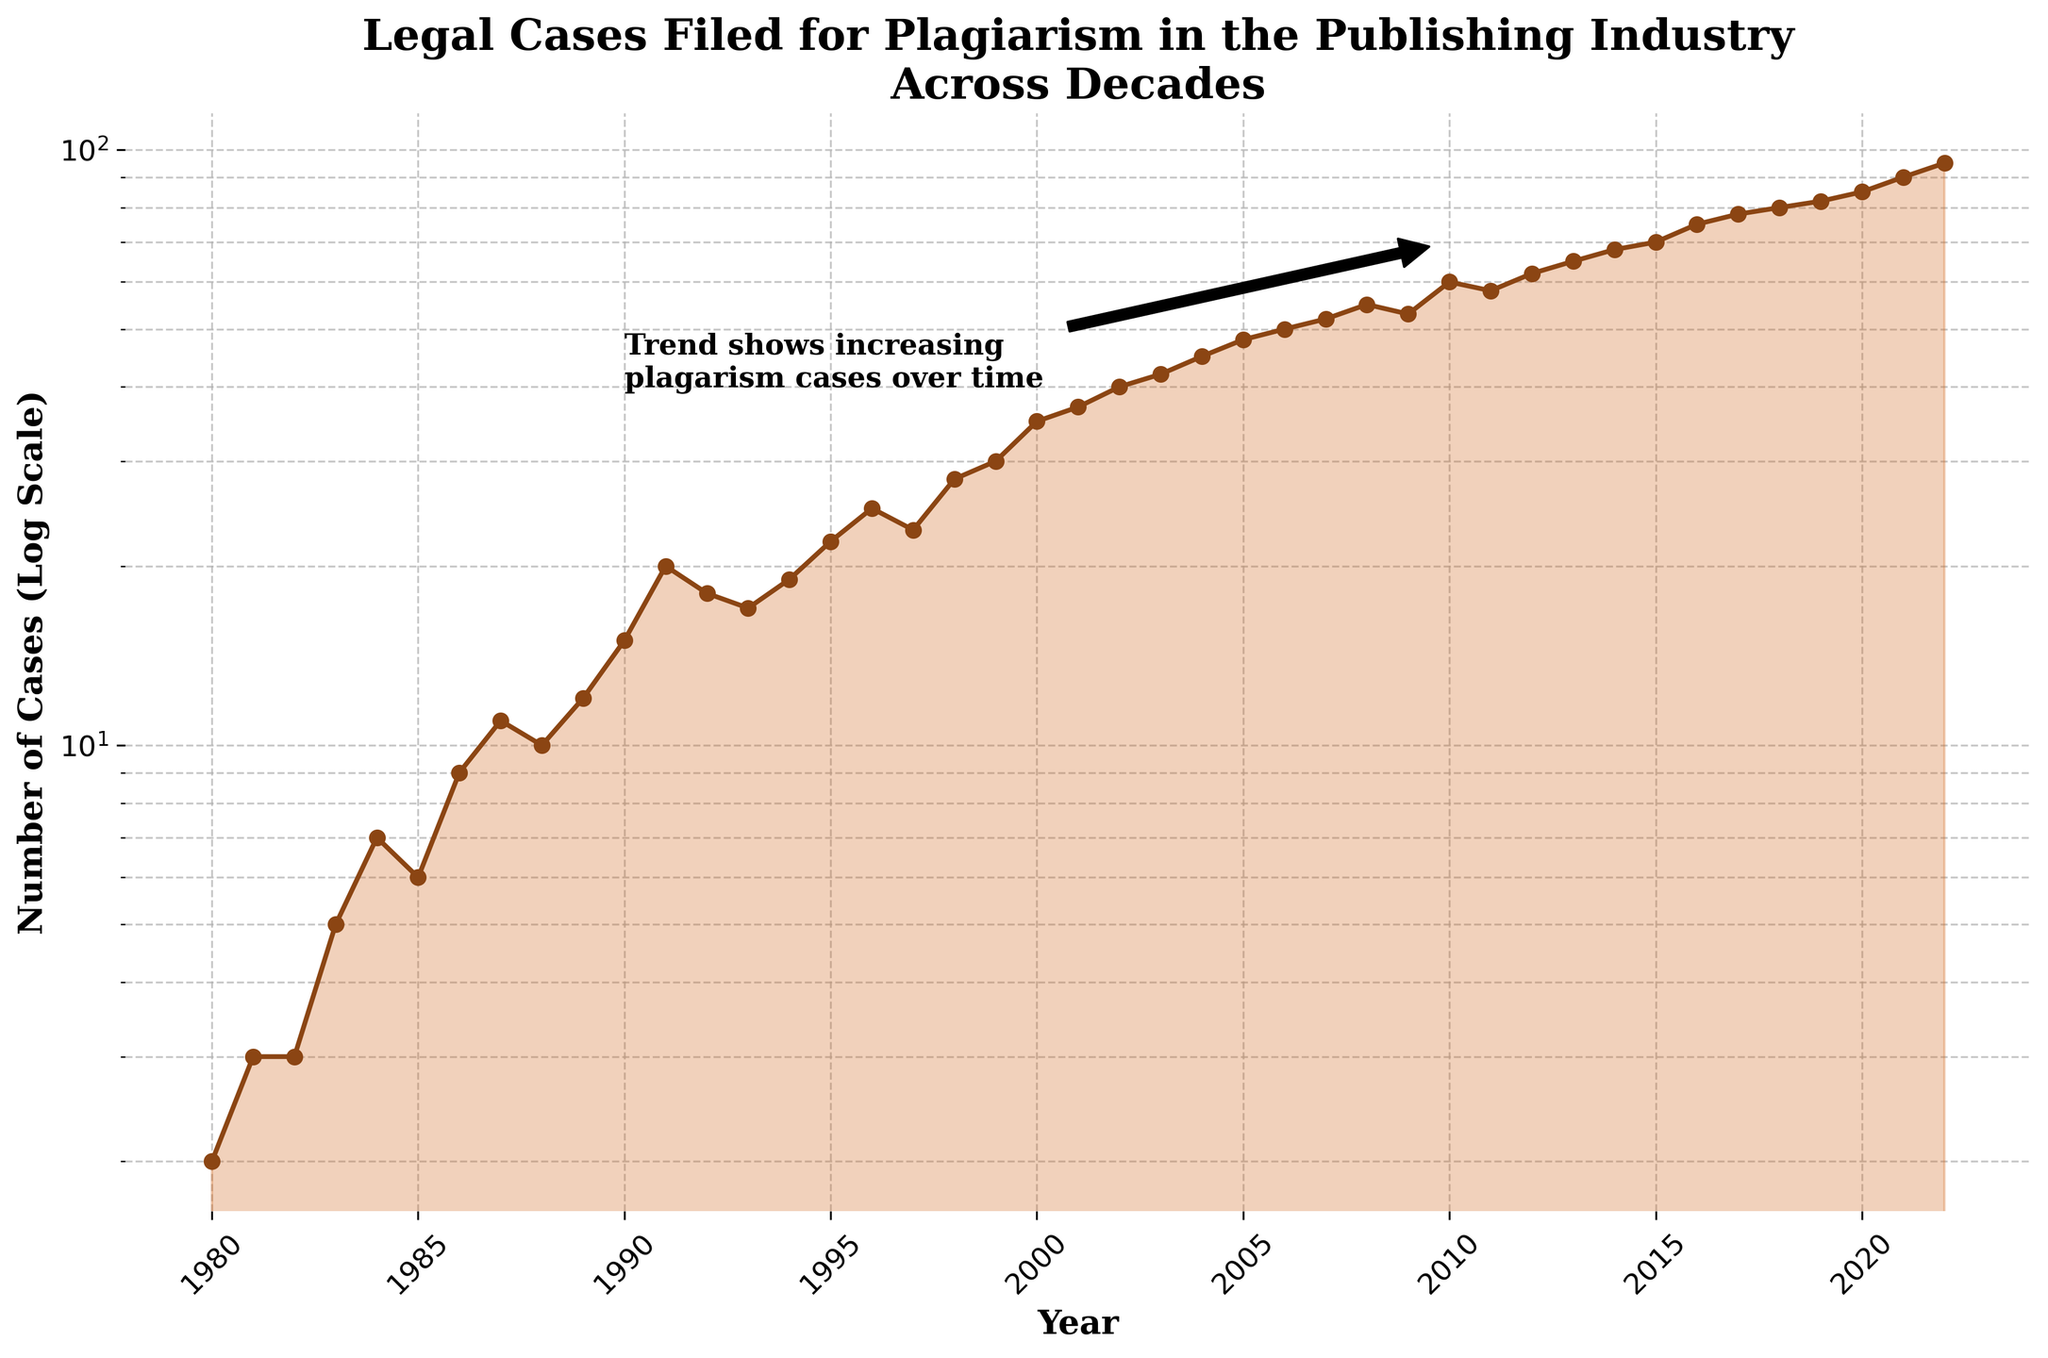What is the title of the figure? The title is usually displayed at the top of the figure, which in this case reads "Legal Cases Filed for Plagiarism in the Publishing Industry Across Decades".
Answer: Legal Cases Filed for Plagiarism in the Publishing Industry Across Decades What is represented by the y-axis in this figure? The y-axis label explains what the vertical axis represents, which is "Number of Cases (Log Scale)".
Answer: Number of Cases (Log Scale) Which year had the highest number of legal cases filed for plagiarism in the publishing industry? By looking at the value that peaks at the rightmost part of the plot, the highest number of cases can be observed in the year 2022.
Answer: 2022 How many cases of plagiarism were filed in 1990? Locate the year 1990 on the x-axis and follow it up to the plotted line, which shows 15 cases.
Answer: 15 By roughly how much did the number of cases increase from 1980 to 2022? Identify the numbers associated with the years 1980 and 2022 on the plot; the cases in 1980 were 2 and in 2022 were 95, resulting in an increase of (95 - 2) = 93 cases.
Answer: 93 In which decade did the number of cases start showing significant growth? The trend should be examined closely, showing noticeable growth starting in the 1990s, as the number of cases began to rise more steeply during this period.
Answer: 1990s What is the log-scale representation of 60 cases on the y-axis? Since the plot uses a log scale on the y-axis, the log-scale representation of 60 cases aligns with 60 on this axis. This doesn't require detailed calculation but confirms observation.
Answer: 60 Which year showed a sudden dip in legal cases filed for plagiarism? Identify the year where the plotted line dips. Notably, 2009 shows a decrease from 55 cases in the previous year to 53 cases.
Answer: 2009 What's the average number of cases filed per year from 2010 to 2020? Sum the cases for each year from 2010 to 2020 and divide by the number of years: (60+58+62+65+68+70+75+78+80+82+85) / 11 = 703 / 11, which is approximately 63.91.
Answer: 63.91 Compare the number of cases in the years 1988 and 2011. Which year had more cases, and by how many? Assessing the values for each year: 1988 had 10 cases, and 2011 had 58. Subtracting, (58 - 10) = 48 more cases in 2011.
Answer: 2011, 48 